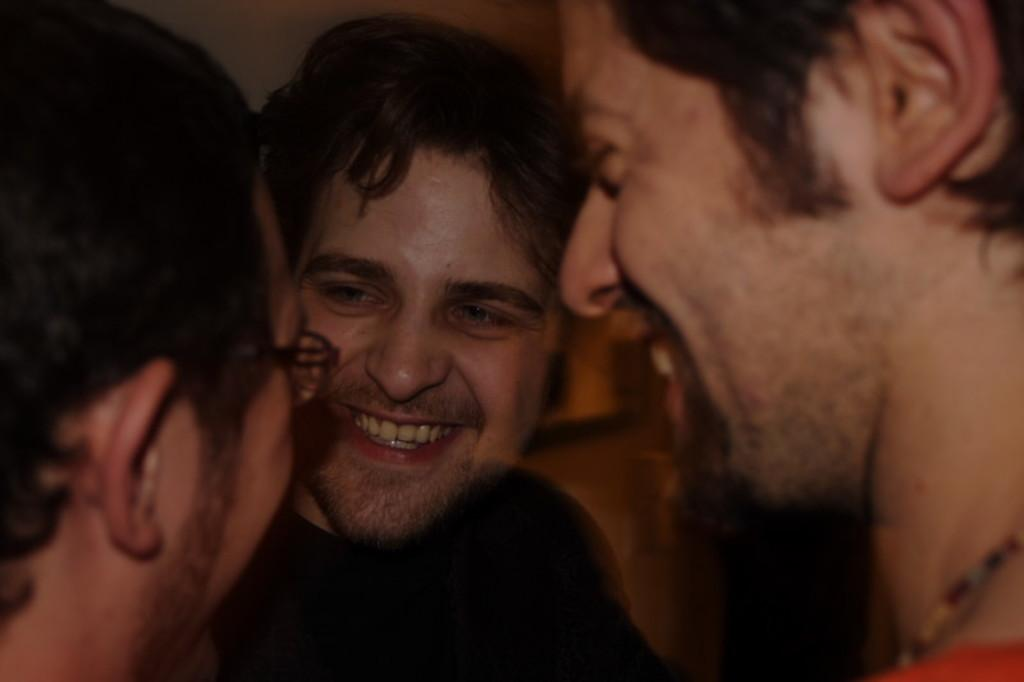Who or what is located in the center of the image? There are people in the center of the image. What can be seen in the background of the image? There is a wall visible in the background of the image. What type of ring is being traded between the people in the image? There is no ring or trade activity present in the image; it only features people and a wall in the background. 